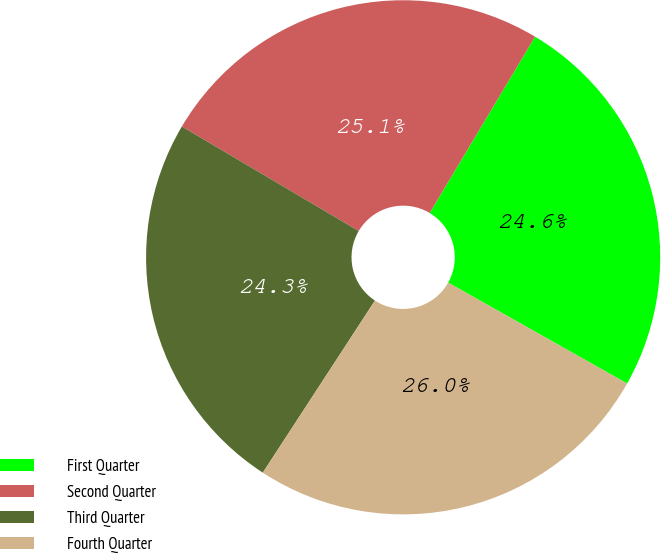Convert chart. <chart><loc_0><loc_0><loc_500><loc_500><pie_chart><fcel>First Quarter<fcel>Second Quarter<fcel>Third Quarter<fcel>Fourth Quarter<nl><fcel>24.59%<fcel>25.08%<fcel>24.3%<fcel>26.02%<nl></chart> 